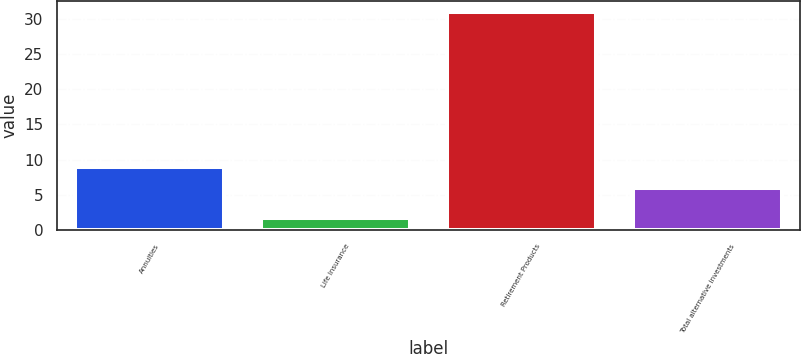Convert chart to OTSL. <chart><loc_0><loc_0><loc_500><loc_500><bar_chart><fcel>Annuities<fcel>Life Insurance<fcel>Retirement Products<fcel>Total alternative investments<nl><fcel>9<fcel>1.72<fcel>31<fcel>6<nl></chart> 